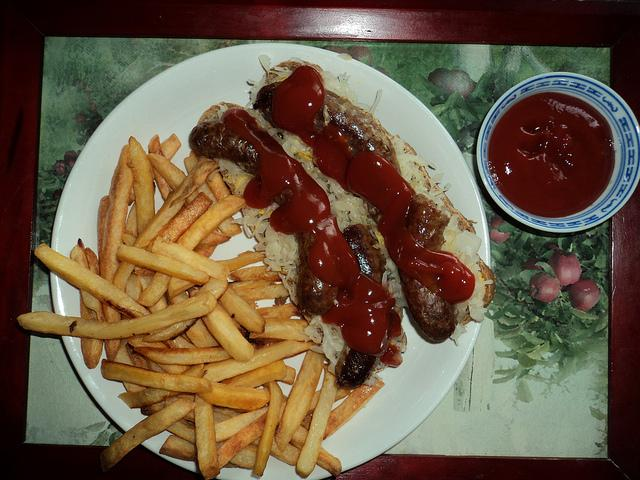What is the red sauce that is covering the hot dog sausages? ketchup 